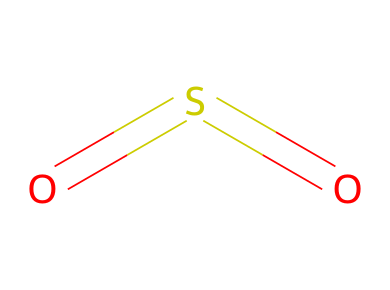What is the molecular formula of sulfur dioxide? The chemical structure shows one sulfur atom and two oxygen atoms, represented as SO2.
Answer: SO2 How many total atoms are present in this molecule? The structure contains one sulfur atom and two oxygen atoms, giving a total of three atoms.
Answer: 3 What type of bonds are present in sulfur dioxide? The visual structure indicates double bonds between the sulfur atom and each of the oxygen atoms.
Answer: double bonds What is the oxidation state of sulfur in this compound? Sulfur dioxide has sulfur in the +4 oxidation state, as deduced from the bonds with the oxygen atoms and their typical oxidation states.
Answer: +4 What is a common source of sulfur dioxide pollution? Sulfur dioxide is commonly produced from the combustion of fossil fuels, particularly coal and oil.
Answer: combustion of fossil fuels How does the presence of sulfur dioxide affect air quality? Sulfur dioxide is a significant air pollutant that can lead to respiratory problems and acid rain formation.
Answer: respiratory problems What role does sulfur dioxide play in the atmosphere? Sulfur dioxide can contribute to the formation of sulfate aerosols, which affect climate and air quality.
Answer: climate and air quality 